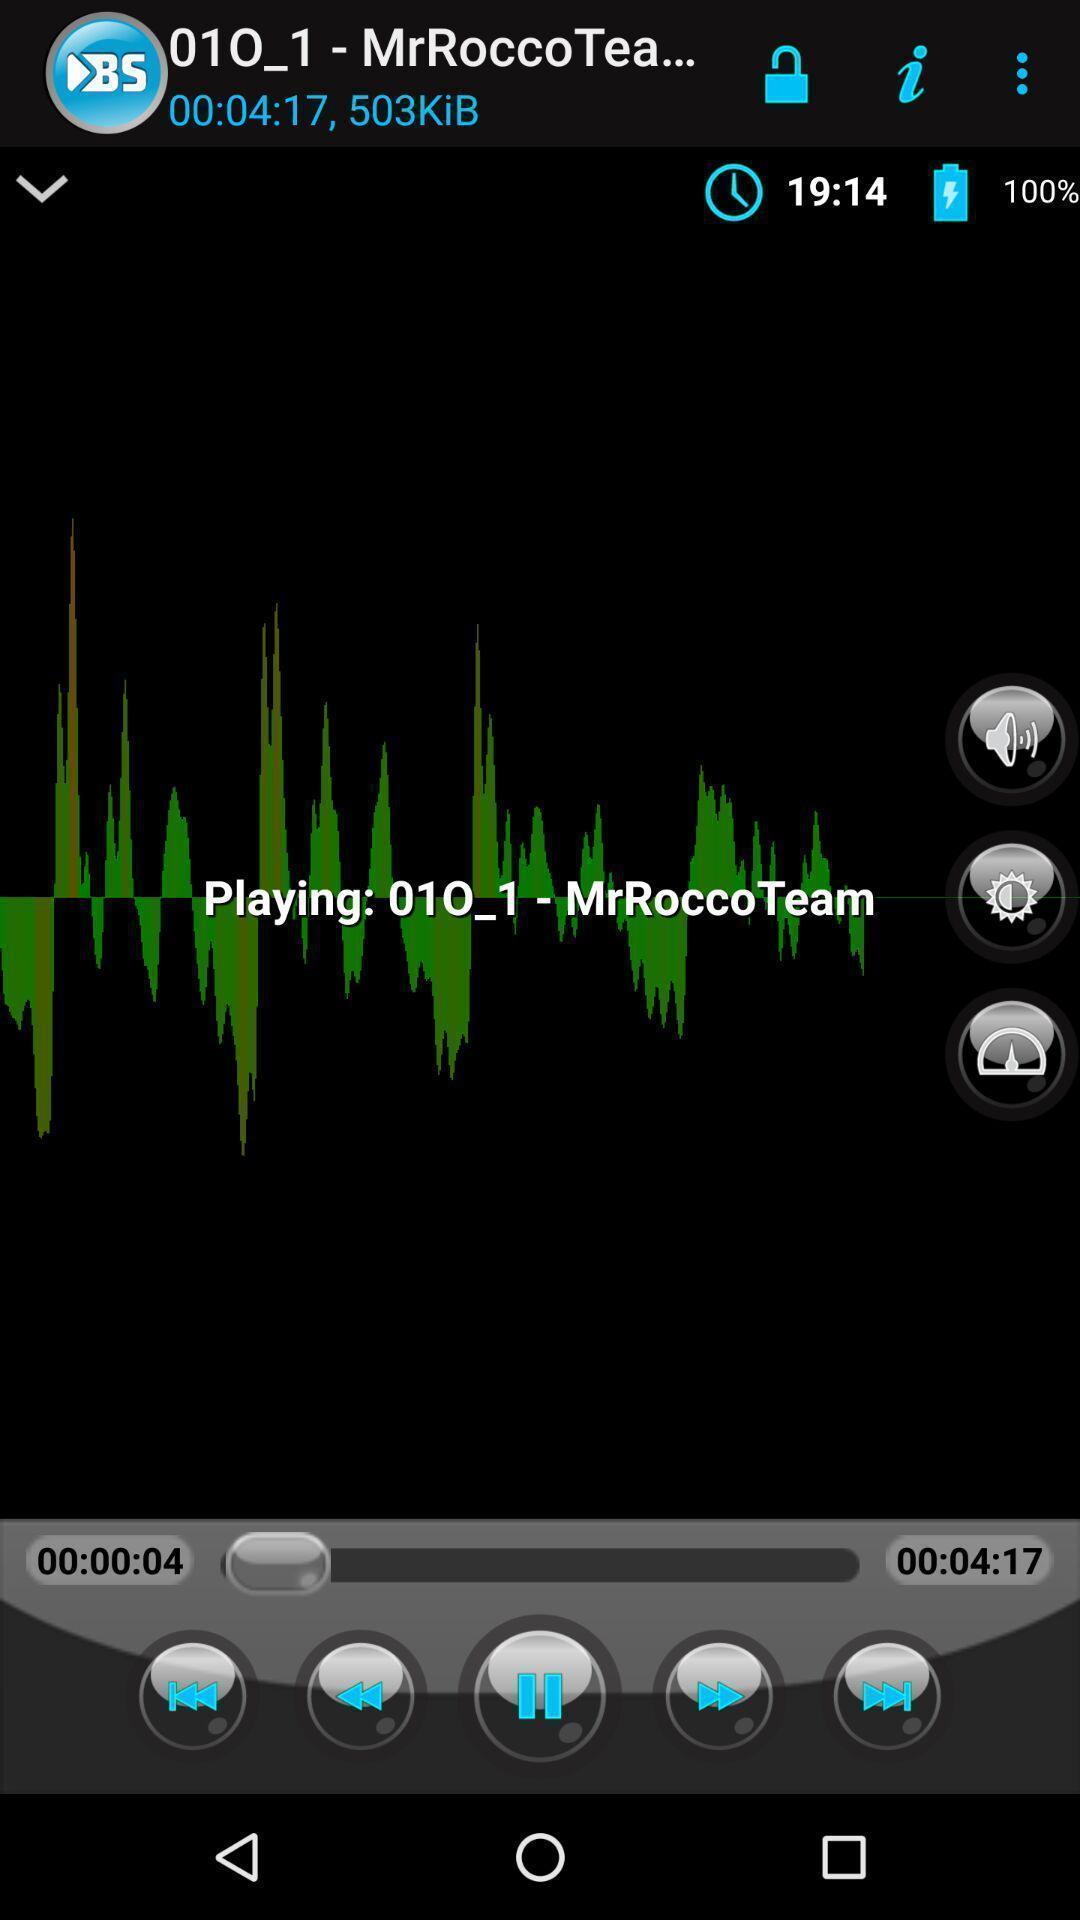Summarize the information in this screenshot. Screen shows player option in a music app. 